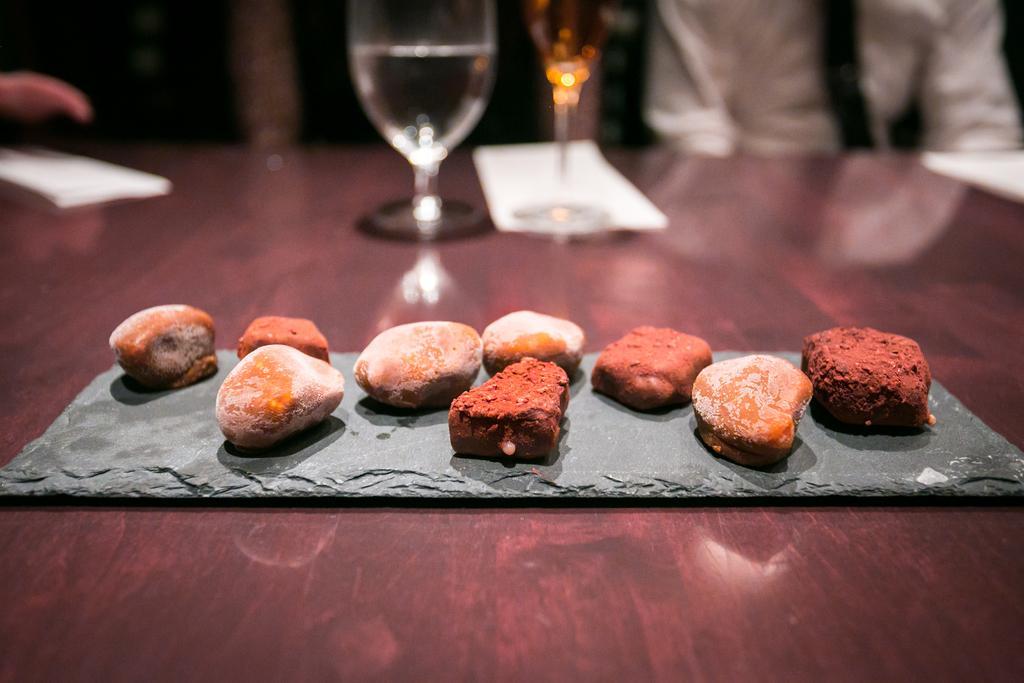In one or two sentences, can you explain what this image depicts? In this image we can see glasses with liquid, tissue papers, and few objects on the table. At the top of the image we can see a person who is truncated. 